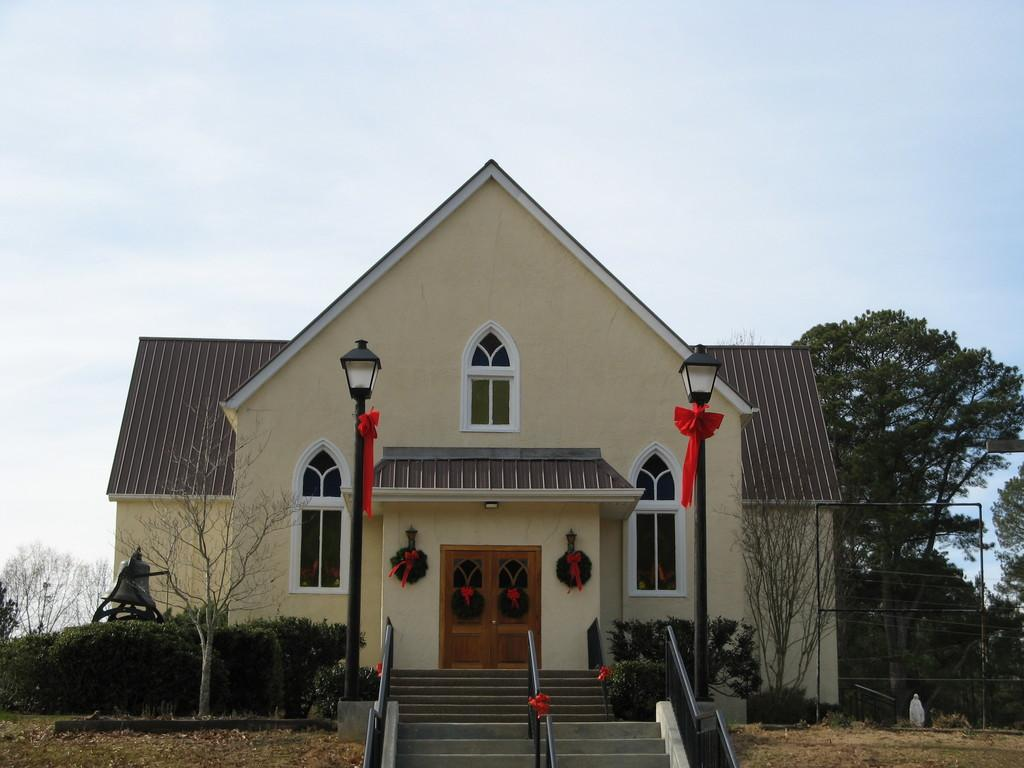What type of structure is present in the image? There is a house in the image. What architectural feature can be seen in the image? There are stairs in the image. What can be seen in the background of the image? There are trees and the sky visible in the background of the image. What type of ring can be seen on the finger of the person standing on the stairs? There is no person or ring visible in the image. 